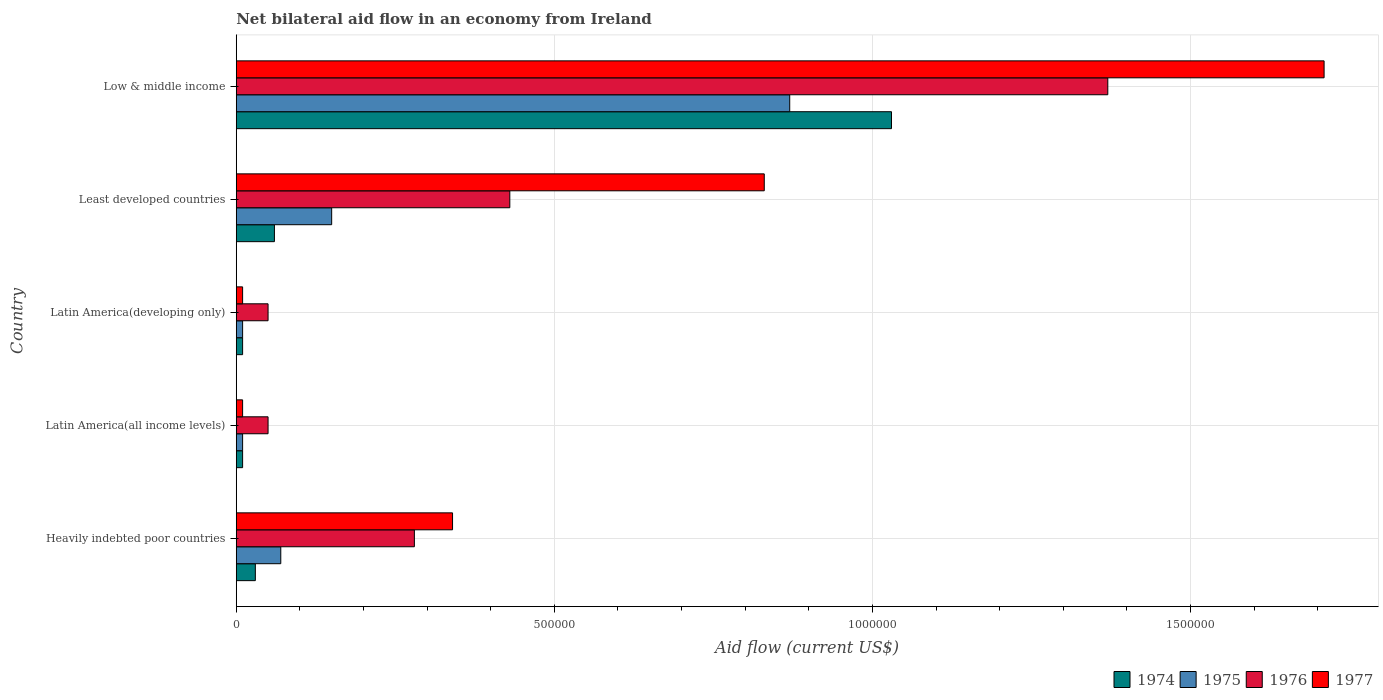How many different coloured bars are there?
Give a very brief answer. 4. How many groups of bars are there?
Provide a short and direct response. 5. How many bars are there on the 3rd tick from the top?
Offer a very short reply. 4. What is the label of the 1st group of bars from the top?
Give a very brief answer. Low & middle income. In how many cases, is the number of bars for a given country not equal to the number of legend labels?
Your answer should be very brief. 0. Across all countries, what is the maximum net bilateral aid flow in 1976?
Provide a short and direct response. 1.37e+06. In which country was the net bilateral aid flow in 1976 maximum?
Offer a terse response. Low & middle income. In which country was the net bilateral aid flow in 1974 minimum?
Make the answer very short. Latin America(all income levels). What is the total net bilateral aid flow in 1975 in the graph?
Your answer should be compact. 1.11e+06. What is the difference between the net bilateral aid flow in 1975 in Heavily indebted poor countries and that in Least developed countries?
Ensure brevity in your answer.  -8.00e+04. What is the difference between the net bilateral aid flow in 1975 in Heavily indebted poor countries and the net bilateral aid flow in 1977 in Latin America(developing only)?
Keep it short and to the point. 6.00e+04. What is the average net bilateral aid flow in 1977 per country?
Provide a short and direct response. 5.80e+05. In how many countries, is the net bilateral aid flow in 1974 greater than 900000 US$?
Provide a succinct answer. 1. Is the difference between the net bilateral aid flow in 1975 in Heavily indebted poor countries and Latin America(developing only) greater than the difference between the net bilateral aid flow in 1976 in Heavily indebted poor countries and Latin America(developing only)?
Offer a terse response. No. What is the difference between the highest and the second highest net bilateral aid flow in 1974?
Offer a very short reply. 9.70e+05. What is the difference between the highest and the lowest net bilateral aid flow in 1975?
Your answer should be compact. 8.60e+05. What does the 4th bar from the top in Latin America(developing only) represents?
Your answer should be compact. 1974. What does the 3rd bar from the bottom in Low & middle income represents?
Keep it short and to the point. 1976. How many bars are there?
Your answer should be very brief. 20. Are the values on the major ticks of X-axis written in scientific E-notation?
Provide a succinct answer. No. Does the graph contain any zero values?
Ensure brevity in your answer.  No. Does the graph contain grids?
Keep it short and to the point. Yes. Where does the legend appear in the graph?
Your answer should be very brief. Bottom right. What is the title of the graph?
Your response must be concise. Net bilateral aid flow in an economy from Ireland. Does "1988" appear as one of the legend labels in the graph?
Provide a succinct answer. No. What is the label or title of the X-axis?
Make the answer very short. Aid flow (current US$). What is the Aid flow (current US$) in 1974 in Heavily indebted poor countries?
Offer a very short reply. 3.00e+04. What is the Aid flow (current US$) in 1976 in Heavily indebted poor countries?
Provide a succinct answer. 2.80e+05. What is the Aid flow (current US$) in 1977 in Heavily indebted poor countries?
Offer a terse response. 3.40e+05. What is the Aid flow (current US$) of 1974 in Latin America(all income levels)?
Offer a very short reply. 10000. What is the Aid flow (current US$) in 1977 in Latin America(all income levels)?
Keep it short and to the point. 10000. What is the Aid flow (current US$) of 1975 in Latin America(developing only)?
Your answer should be very brief. 10000. What is the Aid flow (current US$) in 1976 in Latin America(developing only)?
Give a very brief answer. 5.00e+04. What is the Aid flow (current US$) of 1977 in Latin America(developing only)?
Ensure brevity in your answer.  10000. What is the Aid flow (current US$) in 1977 in Least developed countries?
Make the answer very short. 8.30e+05. What is the Aid flow (current US$) of 1974 in Low & middle income?
Your answer should be compact. 1.03e+06. What is the Aid flow (current US$) of 1975 in Low & middle income?
Your answer should be very brief. 8.70e+05. What is the Aid flow (current US$) of 1976 in Low & middle income?
Offer a terse response. 1.37e+06. What is the Aid flow (current US$) of 1977 in Low & middle income?
Offer a very short reply. 1.71e+06. Across all countries, what is the maximum Aid flow (current US$) of 1974?
Offer a very short reply. 1.03e+06. Across all countries, what is the maximum Aid flow (current US$) in 1975?
Your answer should be compact. 8.70e+05. Across all countries, what is the maximum Aid flow (current US$) in 1976?
Give a very brief answer. 1.37e+06. Across all countries, what is the maximum Aid flow (current US$) of 1977?
Your answer should be compact. 1.71e+06. Across all countries, what is the minimum Aid flow (current US$) of 1974?
Ensure brevity in your answer.  10000. Across all countries, what is the minimum Aid flow (current US$) in 1975?
Your answer should be compact. 10000. Across all countries, what is the minimum Aid flow (current US$) of 1976?
Provide a succinct answer. 5.00e+04. Across all countries, what is the minimum Aid flow (current US$) in 1977?
Give a very brief answer. 10000. What is the total Aid flow (current US$) in 1974 in the graph?
Your answer should be compact. 1.14e+06. What is the total Aid flow (current US$) of 1975 in the graph?
Make the answer very short. 1.11e+06. What is the total Aid flow (current US$) of 1976 in the graph?
Give a very brief answer. 2.18e+06. What is the total Aid flow (current US$) of 1977 in the graph?
Your answer should be very brief. 2.90e+06. What is the difference between the Aid flow (current US$) in 1974 in Heavily indebted poor countries and that in Latin America(all income levels)?
Give a very brief answer. 2.00e+04. What is the difference between the Aid flow (current US$) in 1975 in Heavily indebted poor countries and that in Latin America(all income levels)?
Your response must be concise. 6.00e+04. What is the difference between the Aid flow (current US$) of 1976 in Heavily indebted poor countries and that in Latin America(all income levels)?
Your response must be concise. 2.30e+05. What is the difference between the Aid flow (current US$) in 1975 in Heavily indebted poor countries and that in Latin America(developing only)?
Offer a very short reply. 6.00e+04. What is the difference between the Aid flow (current US$) in 1977 in Heavily indebted poor countries and that in Latin America(developing only)?
Keep it short and to the point. 3.30e+05. What is the difference between the Aid flow (current US$) in 1975 in Heavily indebted poor countries and that in Least developed countries?
Provide a succinct answer. -8.00e+04. What is the difference between the Aid flow (current US$) of 1976 in Heavily indebted poor countries and that in Least developed countries?
Provide a short and direct response. -1.50e+05. What is the difference between the Aid flow (current US$) of 1977 in Heavily indebted poor countries and that in Least developed countries?
Provide a succinct answer. -4.90e+05. What is the difference between the Aid flow (current US$) of 1975 in Heavily indebted poor countries and that in Low & middle income?
Keep it short and to the point. -8.00e+05. What is the difference between the Aid flow (current US$) in 1976 in Heavily indebted poor countries and that in Low & middle income?
Ensure brevity in your answer.  -1.09e+06. What is the difference between the Aid flow (current US$) in 1977 in Heavily indebted poor countries and that in Low & middle income?
Your response must be concise. -1.37e+06. What is the difference between the Aid flow (current US$) in 1974 in Latin America(all income levels) and that in Latin America(developing only)?
Make the answer very short. 0. What is the difference between the Aid flow (current US$) in 1977 in Latin America(all income levels) and that in Latin America(developing only)?
Your response must be concise. 0. What is the difference between the Aid flow (current US$) of 1974 in Latin America(all income levels) and that in Least developed countries?
Ensure brevity in your answer.  -5.00e+04. What is the difference between the Aid flow (current US$) in 1976 in Latin America(all income levels) and that in Least developed countries?
Provide a short and direct response. -3.80e+05. What is the difference between the Aid flow (current US$) of 1977 in Latin America(all income levels) and that in Least developed countries?
Provide a succinct answer. -8.20e+05. What is the difference between the Aid flow (current US$) in 1974 in Latin America(all income levels) and that in Low & middle income?
Provide a succinct answer. -1.02e+06. What is the difference between the Aid flow (current US$) of 1975 in Latin America(all income levels) and that in Low & middle income?
Offer a terse response. -8.60e+05. What is the difference between the Aid flow (current US$) in 1976 in Latin America(all income levels) and that in Low & middle income?
Provide a short and direct response. -1.32e+06. What is the difference between the Aid flow (current US$) in 1977 in Latin America(all income levels) and that in Low & middle income?
Offer a very short reply. -1.70e+06. What is the difference between the Aid flow (current US$) in 1976 in Latin America(developing only) and that in Least developed countries?
Provide a succinct answer. -3.80e+05. What is the difference between the Aid flow (current US$) in 1977 in Latin America(developing only) and that in Least developed countries?
Offer a terse response. -8.20e+05. What is the difference between the Aid flow (current US$) of 1974 in Latin America(developing only) and that in Low & middle income?
Offer a very short reply. -1.02e+06. What is the difference between the Aid flow (current US$) of 1975 in Latin America(developing only) and that in Low & middle income?
Give a very brief answer. -8.60e+05. What is the difference between the Aid flow (current US$) in 1976 in Latin America(developing only) and that in Low & middle income?
Your answer should be very brief. -1.32e+06. What is the difference between the Aid flow (current US$) of 1977 in Latin America(developing only) and that in Low & middle income?
Make the answer very short. -1.70e+06. What is the difference between the Aid flow (current US$) of 1974 in Least developed countries and that in Low & middle income?
Provide a short and direct response. -9.70e+05. What is the difference between the Aid flow (current US$) in 1975 in Least developed countries and that in Low & middle income?
Offer a very short reply. -7.20e+05. What is the difference between the Aid flow (current US$) in 1976 in Least developed countries and that in Low & middle income?
Your answer should be very brief. -9.40e+05. What is the difference between the Aid flow (current US$) in 1977 in Least developed countries and that in Low & middle income?
Ensure brevity in your answer.  -8.80e+05. What is the difference between the Aid flow (current US$) of 1974 in Heavily indebted poor countries and the Aid flow (current US$) of 1976 in Latin America(all income levels)?
Offer a terse response. -2.00e+04. What is the difference between the Aid flow (current US$) in 1974 in Heavily indebted poor countries and the Aid flow (current US$) in 1977 in Latin America(all income levels)?
Your answer should be compact. 2.00e+04. What is the difference between the Aid flow (current US$) of 1975 in Heavily indebted poor countries and the Aid flow (current US$) of 1976 in Latin America(all income levels)?
Provide a short and direct response. 2.00e+04. What is the difference between the Aid flow (current US$) of 1975 in Heavily indebted poor countries and the Aid flow (current US$) of 1977 in Latin America(all income levels)?
Ensure brevity in your answer.  6.00e+04. What is the difference between the Aid flow (current US$) in 1976 in Heavily indebted poor countries and the Aid flow (current US$) in 1977 in Latin America(all income levels)?
Keep it short and to the point. 2.70e+05. What is the difference between the Aid flow (current US$) in 1974 in Heavily indebted poor countries and the Aid flow (current US$) in 1975 in Latin America(developing only)?
Offer a terse response. 2.00e+04. What is the difference between the Aid flow (current US$) in 1975 in Heavily indebted poor countries and the Aid flow (current US$) in 1977 in Latin America(developing only)?
Offer a terse response. 6.00e+04. What is the difference between the Aid flow (current US$) of 1976 in Heavily indebted poor countries and the Aid flow (current US$) of 1977 in Latin America(developing only)?
Offer a very short reply. 2.70e+05. What is the difference between the Aid flow (current US$) in 1974 in Heavily indebted poor countries and the Aid flow (current US$) in 1975 in Least developed countries?
Offer a very short reply. -1.20e+05. What is the difference between the Aid flow (current US$) in 1974 in Heavily indebted poor countries and the Aid flow (current US$) in 1976 in Least developed countries?
Provide a succinct answer. -4.00e+05. What is the difference between the Aid flow (current US$) of 1974 in Heavily indebted poor countries and the Aid flow (current US$) of 1977 in Least developed countries?
Provide a succinct answer. -8.00e+05. What is the difference between the Aid flow (current US$) of 1975 in Heavily indebted poor countries and the Aid flow (current US$) of 1976 in Least developed countries?
Your answer should be compact. -3.60e+05. What is the difference between the Aid flow (current US$) in 1975 in Heavily indebted poor countries and the Aid flow (current US$) in 1977 in Least developed countries?
Ensure brevity in your answer.  -7.60e+05. What is the difference between the Aid flow (current US$) in 1976 in Heavily indebted poor countries and the Aid flow (current US$) in 1977 in Least developed countries?
Ensure brevity in your answer.  -5.50e+05. What is the difference between the Aid flow (current US$) in 1974 in Heavily indebted poor countries and the Aid flow (current US$) in 1975 in Low & middle income?
Your answer should be very brief. -8.40e+05. What is the difference between the Aid flow (current US$) of 1974 in Heavily indebted poor countries and the Aid flow (current US$) of 1976 in Low & middle income?
Your response must be concise. -1.34e+06. What is the difference between the Aid flow (current US$) of 1974 in Heavily indebted poor countries and the Aid flow (current US$) of 1977 in Low & middle income?
Give a very brief answer. -1.68e+06. What is the difference between the Aid flow (current US$) of 1975 in Heavily indebted poor countries and the Aid flow (current US$) of 1976 in Low & middle income?
Make the answer very short. -1.30e+06. What is the difference between the Aid flow (current US$) of 1975 in Heavily indebted poor countries and the Aid flow (current US$) of 1977 in Low & middle income?
Your response must be concise. -1.64e+06. What is the difference between the Aid flow (current US$) in 1976 in Heavily indebted poor countries and the Aid flow (current US$) in 1977 in Low & middle income?
Make the answer very short. -1.43e+06. What is the difference between the Aid flow (current US$) of 1974 in Latin America(all income levels) and the Aid flow (current US$) of 1975 in Latin America(developing only)?
Provide a succinct answer. 0. What is the difference between the Aid flow (current US$) in 1974 in Latin America(all income levels) and the Aid flow (current US$) in 1977 in Latin America(developing only)?
Provide a short and direct response. 0. What is the difference between the Aid flow (current US$) of 1974 in Latin America(all income levels) and the Aid flow (current US$) of 1976 in Least developed countries?
Keep it short and to the point. -4.20e+05. What is the difference between the Aid flow (current US$) in 1974 in Latin America(all income levels) and the Aid flow (current US$) in 1977 in Least developed countries?
Give a very brief answer. -8.20e+05. What is the difference between the Aid flow (current US$) of 1975 in Latin America(all income levels) and the Aid flow (current US$) of 1976 in Least developed countries?
Provide a short and direct response. -4.20e+05. What is the difference between the Aid flow (current US$) in 1975 in Latin America(all income levels) and the Aid flow (current US$) in 1977 in Least developed countries?
Give a very brief answer. -8.20e+05. What is the difference between the Aid flow (current US$) of 1976 in Latin America(all income levels) and the Aid flow (current US$) of 1977 in Least developed countries?
Keep it short and to the point. -7.80e+05. What is the difference between the Aid flow (current US$) of 1974 in Latin America(all income levels) and the Aid flow (current US$) of 1975 in Low & middle income?
Make the answer very short. -8.60e+05. What is the difference between the Aid flow (current US$) of 1974 in Latin America(all income levels) and the Aid flow (current US$) of 1976 in Low & middle income?
Keep it short and to the point. -1.36e+06. What is the difference between the Aid flow (current US$) of 1974 in Latin America(all income levels) and the Aid flow (current US$) of 1977 in Low & middle income?
Provide a succinct answer. -1.70e+06. What is the difference between the Aid flow (current US$) of 1975 in Latin America(all income levels) and the Aid flow (current US$) of 1976 in Low & middle income?
Make the answer very short. -1.36e+06. What is the difference between the Aid flow (current US$) in 1975 in Latin America(all income levels) and the Aid flow (current US$) in 1977 in Low & middle income?
Give a very brief answer. -1.70e+06. What is the difference between the Aid flow (current US$) of 1976 in Latin America(all income levels) and the Aid flow (current US$) of 1977 in Low & middle income?
Keep it short and to the point. -1.66e+06. What is the difference between the Aid flow (current US$) in 1974 in Latin America(developing only) and the Aid flow (current US$) in 1975 in Least developed countries?
Offer a very short reply. -1.40e+05. What is the difference between the Aid flow (current US$) in 1974 in Latin America(developing only) and the Aid flow (current US$) in 1976 in Least developed countries?
Your answer should be very brief. -4.20e+05. What is the difference between the Aid flow (current US$) in 1974 in Latin America(developing only) and the Aid flow (current US$) in 1977 in Least developed countries?
Make the answer very short. -8.20e+05. What is the difference between the Aid flow (current US$) of 1975 in Latin America(developing only) and the Aid flow (current US$) of 1976 in Least developed countries?
Make the answer very short. -4.20e+05. What is the difference between the Aid flow (current US$) in 1975 in Latin America(developing only) and the Aid flow (current US$) in 1977 in Least developed countries?
Give a very brief answer. -8.20e+05. What is the difference between the Aid flow (current US$) of 1976 in Latin America(developing only) and the Aid flow (current US$) of 1977 in Least developed countries?
Your answer should be very brief. -7.80e+05. What is the difference between the Aid flow (current US$) of 1974 in Latin America(developing only) and the Aid flow (current US$) of 1975 in Low & middle income?
Your response must be concise. -8.60e+05. What is the difference between the Aid flow (current US$) of 1974 in Latin America(developing only) and the Aid flow (current US$) of 1976 in Low & middle income?
Offer a very short reply. -1.36e+06. What is the difference between the Aid flow (current US$) of 1974 in Latin America(developing only) and the Aid flow (current US$) of 1977 in Low & middle income?
Your response must be concise. -1.70e+06. What is the difference between the Aid flow (current US$) in 1975 in Latin America(developing only) and the Aid flow (current US$) in 1976 in Low & middle income?
Offer a very short reply. -1.36e+06. What is the difference between the Aid flow (current US$) of 1975 in Latin America(developing only) and the Aid flow (current US$) of 1977 in Low & middle income?
Your answer should be compact. -1.70e+06. What is the difference between the Aid flow (current US$) in 1976 in Latin America(developing only) and the Aid flow (current US$) in 1977 in Low & middle income?
Make the answer very short. -1.66e+06. What is the difference between the Aid flow (current US$) in 1974 in Least developed countries and the Aid flow (current US$) in 1975 in Low & middle income?
Keep it short and to the point. -8.10e+05. What is the difference between the Aid flow (current US$) in 1974 in Least developed countries and the Aid flow (current US$) in 1976 in Low & middle income?
Provide a succinct answer. -1.31e+06. What is the difference between the Aid flow (current US$) of 1974 in Least developed countries and the Aid flow (current US$) of 1977 in Low & middle income?
Your response must be concise. -1.65e+06. What is the difference between the Aid flow (current US$) in 1975 in Least developed countries and the Aid flow (current US$) in 1976 in Low & middle income?
Your response must be concise. -1.22e+06. What is the difference between the Aid flow (current US$) in 1975 in Least developed countries and the Aid flow (current US$) in 1977 in Low & middle income?
Provide a succinct answer. -1.56e+06. What is the difference between the Aid flow (current US$) in 1976 in Least developed countries and the Aid flow (current US$) in 1977 in Low & middle income?
Make the answer very short. -1.28e+06. What is the average Aid flow (current US$) in 1974 per country?
Offer a terse response. 2.28e+05. What is the average Aid flow (current US$) in 1975 per country?
Keep it short and to the point. 2.22e+05. What is the average Aid flow (current US$) of 1976 per country?
Ensure brevity in your answer.  4.36e+05. What is the average Aid flow (current US$) in 1977 per country?
Make the answer very short. 5.80e+05. What is the difference between the Aid flow (current US$) in 1974 and Aid flow (current US$) in 1977 in Heavily indebted poor countries?
Ensure brevity in your answer.  -3.10e+05. What is the difference between the Aid flow (current US$) in 1976 and Aid flow (current US$) in 1977 in Heavily indebted poor countries?
Provide a succinct answer. -6.00e+04. What is the difference between the Aid flow (current US$) in 1974 and Aid flow (current US$) in 1976 in Latin America(all income levels)?
Provide a short and direct response. -4.00e+04. What is the difference between the Aid flow (current US$) of 1974 and Aid flow (current US$) of 1977 in Latin America(all income levels)?
Provide a succinct answer. 0. What is the difference between the Aid flow (current US$) of 1974 and Aid flow (current US$) of 1975 in Latin America(developing only)?
Give a very brief answer. 0. What is the difference between the Aid flow (current US$) in 1974 and Aid flow (current US$) in 1975 in Least developed countries?
Make the answer very short. -9.00e+04. What is the difference between the Aid flow (current US$) in 1974 and Aid flow (current US$) in 1976 in Least developed countries?
Ensure brevity in your answer.  -3.70e+05. What is the difference between the Aid flow (current US$) of 1974 and Aid flow (current US$) of 1977 in Least developed countries?
Give a very brief answer. -7.70e+05. What is the difference between the Aid flow (current US$) of 1975 and Aid flow (current US$) of 1976 in Least developed countries?
Offer a terse response. -2.80e+05. What is the difference between the Aid flow (current US$) in 1975 and Aid flow (current US$) in 1977 in Least developed countries?
Give a very brief answer. -6.80e+05. What is the difference between the Aid flow (current US$) in 1976 and Aid flow (current US$) in 1977 in Least developed countries?
Your response must be concise. -4.00e+05. What is the difference between the Aid flow (current US$) of 1974 and Aid flow (current US$) of 1975 in Low & middle income?
Offer a very short reply. 1.60e+05. What is the difference between the Aid flow (current US$) of 1974 and Aid flow (current US$) of 1977 in Low & middle income?
Your response must be concise. -6.80e+05. What is the difference between the Aid flow (current US$) of 1975 and Aid flow (current US$) of 1976 in Low & middle income?
Your response must be concise. -5.00e+05. What is the difference between the Aid flow (current US$) in 1975 and Aid flow (current US$) in 1977 in Low & middle income?
Keep it short and to the point. -8.40e+05. What is the ratio of the Aid flow (current US$) of 1974 in Heavily indebted poor countries to that in Latin America(all income levels)?
Offer a very short reply. 3. What is the ratio of the Aid flow (current US$) of 1975 in Heavily indebted poor countries to that in Latin America(all income levels)?
Ensure brevity in your answer.  7. What is the ratio of the Aid flow (current US$) in 1976 in Heavily indebted poor countries to that in Latin America(all income levels)?
Your answer should be compact. 5.6. What is the ratio of the Aid flow (current US$) of 1977 in Heavily indebted poor countries to that in Latin America(all income levels)?
Provide a succinct answer. 34. What is the ratio of the Aid flow (current US$) in 1976 in Heavily indebted poor countries to that in Latin America(developing only)?
Your answer should be compact. 5.6. What is the ratio of the Aid flow (current US$) in 1975 in Heavily indebted poor countries to that in Least developed countries?
Keep it short and to the point. 0.47. What is the ratio of the Aid flow (current US$) in 1976 in Heavily indebted poor countries to that in Least developed countries?
Ensure brevity in your answer.  0.65. What is the ratio of the Aid flow (current US$) of 1977 in Heavily indebted poor countries to that in Least developed countries?
Your response must be concise. 0.41. What is the ratio of the Aid flow (current US$) in 1974 in Heavily indebted poor countries to that in Low & middle income?
Provide a succinct answer. 0.03. What is the ratio of the Aid flow (current US$) of 1975 in Heavily indebted poor countries to that in Low & middle income?
Provide a short and direct response. 0.08. What is the ratio of the Aid flow (current US$) of 1976 in Heavily indebted poor countries to that in Low & middle income?
Offer a very short reply. 0.2. What is the ratio of the Aid flow (current US$) in 1977 in Heavily indebted poor countries to that in Low & middle income?
Your response must be concise. 0.2. What is the ratio of the Aid flow (current US$) in 1975 in Latin America(all income levels) to that in Latin America(developing only)?
Provide a short and direct response. 1. What is the ratio of the Aid flow (current US$) of 1976 in Latin America(all income levels) to that in Latin America(developing only)?
Offer a very short reply. 1. What is the ratio of the Aid flow (current US$) of 1975 in Latin America(all income levels) to that in Least developed countries?
Offer a very short reply. 0.07. What is the ratio of the Aid flow (current US$) in 1976 in Latin America(all income levels) to that in Least developed countries?
Make the answer very short. 0.12. What is the ratio of the Aid flow (current US$) of 1977 in Latin America(all income levels) to that in Least developed countries?
Provide a short and direct response. 0.01. What is the ratio of the Aid flow (current US$) in 1974 in Latin America(all income levels) to that in Low & middle income?
Your answer should be very brief. 0.01. What is the ratio of the Aid flow (current US$) of 1975 in Latin America(all income levels) to that in Low & middle income?
Keep it short and to the point. 0.01. What is the ratio of the Aid flow (current US$) of 1976 in Latin America(all income levels) to that in Low & middle income?
Make the answer very short. 0.04. What is the ratio of the Aid flow (current US$) in 1977 in Latin America(all income levels) to that in Low & middle income?
Ensure brevity in your answer.  0.01. What is the ratio of the Aid flow (current US$) of 1974 in Latin America(developing only) to that in Least developed countries?
Make the answer very short. 0.17. What is the ratio of the Aid flow (current US$) in 1975 in Latin America(developing only) to that in Least developed countries?
Give a very brief answer. 0.07. What is the ratio of the Aid flow (current US$) in 1976 in Latin America(developing only) to that in Least developed countries?
Offer a very short reply. 0.12. What is the ratio of the Aid flow (current US$) of 1977 in Latin America(developing only) to that in Least developed countries?
Offer a very short reply. 0.01. What is the ratio of the Aid flow (current US$) in 1974 in Latin America(developing only) to that in Low & middle income?
Keep it short and to the point. 0.01. What is the ratio of the Aid flow (current US$) of 1975 in Latin America(developing only) to that in Low & middle income?
Give a very brief answer. 0.01. What is the ratio of the Aid flow (current US$) of 1976 in Latin America(developing only) to that in Low & middle income?
Your answer should be compact. 0.04. What is the ratio of the Aid flow (current US$) in 1977 in Latin America(developing only) to that in Low & middle income?
Offer a terse response. 0.01. What is the ratio of the Aid flow (current US$) of 1974 in Least developed countries to that in Low & middle income?
Provide a succinct answer. 0.06. What is the ratio of the Aid flow (current US$) of 1975 in Least developed countries to that in Low & middle income?
Your response must be concise. 0.17. What is the ratio of the Aid flow (current US$) of 1976 in Least developed countries to that in Low & middle income?
Provide a short and direct response. 0.31. What is the ratio of the Aid flow (current US$) of 1977 in Least developed countries to that in Low & middle income?
Provide a succinct answer. 0.49. What is the difference between the highest and the second highest Aid flow (current US$) of 1974?
Make the answer very short. 9.70e+05. What is the difference between the highest and the second highest Aid flow (current US$) in 1975?
Give a very brief answer. 7.20e+05. What is the difference between the highest and the second highest Aid flow (current US$) of 1976?
Your answer should be very brief. 9.40e+05. What is the difference between the highest and the second highest Aid flow (current US$) of 1977?
Make the answer very short. 8.80e+05. What is the difference between the highest and the lowest Aid flow (current US$) of 1974?
Provide a succinct answer. 1.02e+06. What is the difference between the highest and the lowest Aid flow (current US$) of 1975?
Offer a terse response. 8.60e+05. What is the difference between the highest and the lowest Aid flow (current US$) of 1976?
Give a very brief answer. 1.32e+06. What is the difference between the highest and the lowest Aid flow (current US$) of 1977?
Ensure brevity in your answer.  1.70e+06. 